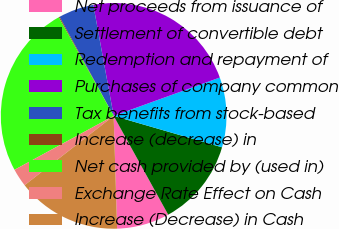Convert chart to OTSL. <chart><loc_0><loc_0><loc_500><loc_500><pie_chart><fcel>Net proceeds from issuance of<fcel>Settlement of convertible debt<fcel>Redemption and repayment of<fcel>Purchases of company common<fcel>Tax benefits from stock-based<fcel>Increase (decrease) in<fcel>Net cash provided by (used in)<fcel>Exchange Rate Effect on Cash<fcel>Increase (Decrease) in Cash<nl><fcel>7.54%<fcel>12.48%<fcel>10.01%<fcel>22.37%<fcel>5.07%<fcel>0.13%<fcel>24.84%<fcel>2.6%<fcel>14.96%<nl></chart> 